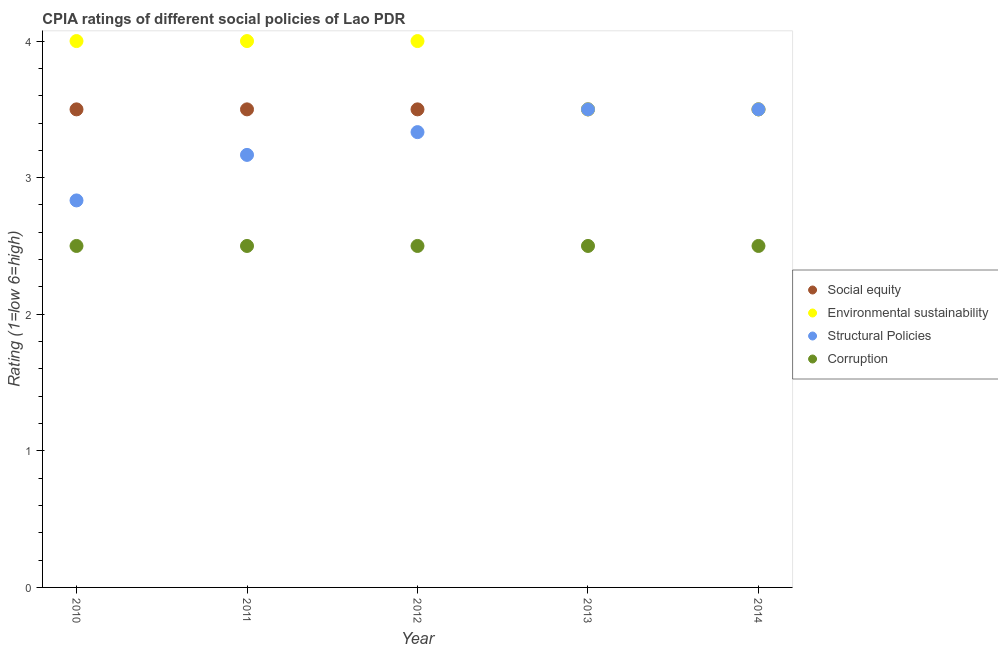How many different coloured dotlines are there?
Keep it short and to the point. 4. Is the number of dotlines equal to the number of legend labels?
Your answer should be very brief. Yes. What is the cpia rating of structural policies in 2012?
Your answer should be very brief. 3.33. Across all years, what is the maximum cpia rating of structural policies?
Make the answer very short. 3.5. In which year was the cpia rating of environmental sustainability maximum?
Keep it short and to the point. 2010. What is the difference between the cpia rating of environmental sustainability in 2011 and the cpia rating of structural policies in 2012?
Make the answer very short. 0.67. What is the average cpia rating of corruption per year?
Offer a very short reply. 2.5. What is the ratio of the cpia rating of corruption in 2013 to that in 2014?
Keep it short and to the point. 1. Is the cpia rating of corruption in 2012 less than that in 2014?
Keep it short and to the point. No. What is the difference between the highest and the second highest cpia rating of structural policies?
Offer a very short reply. 0. What is the difference between the highest and the lowest cpia rating of social equity?
Ensure brevity in your answer.  0. Is the sum of the cpia rating of environmental sustainability in 2012 and 2014 greater than the maximum cpia rating of social equity across all years?
Keep it short and to the point. Yes. How many years are there in the graph?
Your answer should be very brief. 5. Are the values on the major ticks of Y-axis written in scientific E-notation?
Your response must be concise. No. How many legend labels are there?
Offer a terse response. 4. What is the title of the graph?
Keep it short and to the point. CPIA ratings of different social policies of Lao PDR. Does "Primary schools" appear as one of the legend labels in the graph?
Your answer should be very brief. No. What is the label or title of the X-axis?
Provide a short and direct response. Year. What is the Rating (1=low 6=high) in Social equity in 2010?
Ensure brevity in your answer.  3.5. What is the Rating (1=low 6=high) of Environmental sustainability in 2010?
Your response must be concise. 4. What is the Rating (1=low 6=high) of Structural Policies in 2010?
Make the answer very short. 2.83. What is the Rating (1=low 6=high) in Environmental sustainability in 2011?
Give a very brief answer. 4. What is the Rating (1=low 6=high) of Structural Policies in 2011?
Your answer should be compact. 3.17. What is the Rating (1=low 6=high) in Social equity in 2012?
Your answer should be compact. 3.5. What is the Rating (1=low 6=high) in Structural Policies in 2012?
Your answer should be compact. 3.33. What is the Rating (1=low 6=high) in Corruption in 2012?
Keep it short and to the point. 2.5. What is the Rating (1=low 6=high) of Social equity in 2013?
Provide a short and direct response. 3.5. What is the Rating (1=low 6=high) of Structural Policies in 2013?
Ensure brevity in your answer.  3.5. What is the Rating (1=low 6=high) in Structural Policies in 2014?
Keep it short and to the point. 3.5. What is the Rating (1=low 6=high) of Corruption in 2014?
Your answer should be compact. 2.5. Across all years, what is the maximum Rating (1=low 6=high) in Environmental sustainability?
Your answer should be very brief. 4. Across all years, what is the maximum Rating (1=low 6=high) in Structural Policies?
Provide a succinct answer. 3.5. Across all years, what is the maximum Rating (1=low 6=high) of Corruption?
Keep it short and to the point. 2.5. Across all years, what is the minimum Rating (1=low 6=high) in Environmental sustainability?
Ensure brevity in your answer.  3.5. Across all years, what is the minimum Rating (1=low 6=high) of Structural Policies?
Ensure brevity in your answer.  2.83. Across all years, what is the minimum Rating (1=low 6=high) of Corruption?
Offer a very short reply. 2.5. What is the total Rating (1=low 6=high) in Social equity in the graph?
Provide a short and direct response. 17.5. What is the total Rating (1=low 6=high) in Structural Policies in the graph?
Provide a short and direct response. 16.33. What is the total Rating (1=low 6=high) in Corruption in the graph?
Make the answer very short. 12.5. What is the difference between the Rating (1=low 6=high) of Social equity in 2010 and that in 2011?
Make the answer very short. 0. What is the difference between the Rating (1=low 6=high) of Environmental sustainability in 2010 and that in 2011?
Your answer should be very brief. 0. What is the difference between the Rating (1=low 6=high) of Social equity in 2010 and that in 2012?
Your answer should be very brief. 0. What is the difference between the Rating (1=low 6=high) in Structural Policies in 2010 and that in 2012?
Offer a terse response. -0.5. What is the difference between the Rating (1=low 6=high) in Corruption in 2010 and that in 2012?
Your response must be concise. 0. What is the difference between the Rating (1=low 6=high) in Social equity in 2010 and that in 2013?
Offer a very short reply. 0. What is the difference between the Rating (1=low 6=high) of Structural Policies in 2010 and that in 2013?
Provide a succinct answer. -0.67. What is the difference between the Rating (1=low 6=high) of Corruption in 2010 and that in 2014?
Your answer should be compact. 0. What is the difference between the Rating (1=low 6=high) in Social equity in 2011 and that in 2012?
Provide a succinct answer. 0. What is the difference between the Rating (1=low 6=high) of Social equity in 2011 and that in 2013?
Give a very brief answer. 0. What is the difference between the Rating (1=low 6=high) in Environmental sustainability in 2011 and that in 2013?
Ensure brevity in your answer.  0.5. What is the difference between the Rating (1=low 6=high) of Structural Policies in 2011 and that in 2013?
Your response must be concise. -0.33. What is the difference between the Rating (1=low 6=high) in Corruption in 2011 and that in 2013?
Give a very brief answer. 0. What is the difference between the Rating (1=low 6=high) of Structural Policies in 2011 and that in 2014?
Make the answer very short. -0.33. What is the difference between the Rating (1=low 6=high) in Social equity in 2012 and that in 2013?
Keep it short and to the point. 0. What is the difference between the Rating (1=low 6=high) in Structural Policies in 2012 and that in 2013?
Your answer should be compact. -0.17. What is the difference between the Rating (1=low 6=high) of Corruption in 2012 and that in 2013?
Ensure brevity in your answer.  0. What is the difference between the Rating (1=low 6=high) in Social equity in 2012 and that in 2014?
Provide a short and direct response. 0. What is the difference between the Rating (1=low 6=high) in Structural Policies in 2012 and that in 2014?
Offer a terse response. -0.17. What is the difference between the Rating (1=low 6=high) of Social equity in 2013 and that in 2014?
Provide a succinct answer. 0. What is the difference between the Rating (1=low 6=high) of Social equity in 2010 and the Rating (1=low 6=high) of Structural Policies in 2011?
Offer a very short reply. 0.33. What is the difference between the Rating (1=low 6=high) in Environmental sustainability in 2010 and the Rating (1=low 6=high) in Structural Policies in 2011?
Your answer should be compact. 0.83. What is the difference between the Rating (1=low 6=high) in Environmental sustainability in 2010 and the Rating (1=low 6=high) in Corruption in 2011?
Offer a very short reply. 1.5. What is the difference between the Rating (1=low 6=high) in Environmental sustainability in 2010 and the Rating (1=low 6=high) in Structural Policies in 2012?
Make the answer very short. 0.67. What is the difference between the Rating (1=low 6=high) of Social equity in 2010 and the Rating (1=low 6=high) of Environmental sustainability in 2013?
Offer a very short reply. 0. What is the difference between the Rating (1=low 6=high) of Social equity in 2010 and the Rating (1=low 6=high) of Corruption in 2013?
Offer a very short reply. 1. What is the difference between the Rating (1=low 6=high) of Environmental sustainability in 2010 and the Rating (1=low 6=high) of Corruption in 2013?
Offer a very short reply. 1.5. What is the difference between the Rating (1=low 6=high) in Social equity in 2010 and the Rating (1=low 6=high) in Environmental sustainability in 2014?
Your answer should be compact. 0. What is the difference between the Rating (1=low 6=high) of Environmental sustainability in 2010 and the Rating (1=low 6=high) of Corruption in 2014?
Your answer should be very brief. 1.5. What is the difference between the Rating (1=low 6=high) in Social equity in 2011 and the Rating (1=low 6=high) in Environmental sustainability in 2012?
Offer a very short reply. -0.5. What is the difference between the Rating (1=low 6=high) of Social equity in 2011 and the Rating (1=low 6=high) of Structural Policies in 2012?
Ensure brevity in your answer.  0.17. What is the difference between the Rating (1=low 6=high) in Social equity in 2011 and the Rating (1=low 6=high) in Corruption in 2012?
Make the answer very short. 1. What is the difference between the Rating (1=low 6=high) of Environmental sustainability in 2011 and the Rating (1=low 6=high) of Structural Policies in 2012?
Offer a very short reply. 0.67. What is the difference between the Rating (1=low 6=high) of Environmental sustainability in 2011 and the Rating (1=low 6=high) of Corruption in 2012?
Give a very brief answer. 1.5. What is the difference between the Rating (1=low 6=high) in Social equity in 2011 and the Rating (1=low 6=high) in Structural Policies in 2013?
Your response must be concise. 0. What is the difference between the Rating (1=low 6=high) of Social equity in 2011 and the Rating (1=low 6=high) of Corruption in 2013?
Ensure brevity in your answer.  1. What is the difference between the Rating (1=low 6=high) of Environmental sustainability in 2011 and the Rating (1=low 6=high) of Structural Policies in 2013?
Provide a short and direct response. 0.5. What is the difference between the Rating (1=low 6=high) in Environmental sustainability in 2011 and the Rating (1=low 6=high) in Structural Policies in 2014?
Ensure brevity in your answer.  0.5. What is the difference between the Rating (1=low 6=high) in Environmental sustainability in 2011 and the Rating (1=low 6=high) in Corruption in 2014?
Provide a short and direct response. 1.5. What is the difference between the Rating (1=low 6=high) in Social equity in 2012 and the Rating (1=low 6=high) in Environmental sustainability in 2013?
Give a very brief answer. 0. What is the difference between the Rating (1=low 6=high) of Social equity in 2012 and the Rating (1=low 6=high) of Structural Policies in 2014?
Keep it short and to the point. 0. What is the difference between the Rating (1=low 6=high) of Social equity in 2013 and the Rating (1=low 6=high) of Environmental sustainability in 2014?
Give a very brief answer. 0. What is the difference between the Rating (1=low 6=high) of Environmental sustainability in 2013 and the Rating (1=low 6=high) of Structural Policies in 2014?
Provide a succinct answer. 0. What is the difference between the Rating (1=low 6=high) in Environmental sustainability in 2013 and the Rating (1=low 6=high) in Corruption in 2014?
Give a very brief answer. 1. What is the average Rating (1=low 6=high) in Social equity per year?
Provide a short and direct response. 3.5. What is the average Rating (1=low 6=high) in Structural Policies per year?
Offer a terse response. 3.27. What is the average Rating (1=low 6=high) of Corruption per year?
Make the answer very short. 2.5. In the year 2010, what is the difference between the Rating (1=low 6=high) in Social equity and Rating (1=low 6=high) in Environmental sustainability?
Provide a succinct answer. -0.5. In the year 2010, what is the difference between the Rating (1=low 6=high) of Social equity and Rating (1=low 6=high) of Structural Policies?
Provide a short and direct response. 0.67. In the year 2010, what is the difference between the Rating (1=low 6=high) of Structural Policies and Rating (1=low 6=high) of Corruption?
Keep it short and to the point. 0.33. In the year 2011, what is the difference between the Rating (1=low 6=high) in Social equity and Rating (1=low 6=high) in Structural Policies?
Your response must be concise. 0.33. In the year 2011, what is the difference between the Rating (1=low 6=high) in Environmental sustainability and Rating (1=low 6=high) in Corruption?
Provide a short and direct response. 1.5. In the year 2013, what is the difference between the Rating (1=low 6=high) of Social equity and Rating (1=low 6=high) of Structural Policies?
Offer a very short reply. 0. In the year 2013, what is the difference between the Rating (1=low 6=high) in Environmental sustainability and Rating (1=low 6=high) in Structural Policies?
Provide a short and direct response. 0. In the year 2013, what is the difference between the Rating (1=low 6=high) in Environmental sustainability and Rating (1=low 6=high) in Corruption?
Offer a terse response. 1. In the year 2013, what is the difference between the Rating (1=low 6=high) in Structural Policies and Rating (1=low 6=high) in Corruption?
Make the answer very short. 1. In the year 2014, what is the difference between the Rating (1=low 6=high) in Social equity and Rating (1=low 6=high) in Structural Policies?
Your answer should be compact. 0. What is the ratio of the Rating (1=low 6=high) in Environmental sustainability in 2010 to that in 2011?
Make the answer very short. 1. What is the ratio of the Rating (1=low 6=high) in Structural Policies in 2010 to that in 2011?
Ensure brevity in your answer.  0.89. What is the ratio of the Rating (1=low 6=high) of Environmental sustainability in 2010 to that in 2012?
Make the answer very short. 1. What is the ratio of the Rating (1=low 6=high) in Corruption in 2010 to that in 2012?
Ensure brevity in your answer.  1. What is the ratio of the Rating (1=low 6=high) of Structural Policies in 2010 to that in 2013?
Your answer should be very brief. 0.81. What is the ratio of the Rating (1=low 6=high) of Corruption in 2010 to that in 2013?
Provide a short and direct response. 1. What is the ratio of the Rating (1=low 6=high) of Social equity in 2010 to that in 2014?
Provide a short and direct response. 1. What is the ratio of the Rating (1=low 6=high) in Structural Policies in 2010 to that in 2014?
Give a very brief answer. 0.81. What is the ratio of the Rating (1=low 6=high) of Corruption in 2010 to that in 2014?
Your answer should be very brief. 1. What is the ratio of the Rating (1=low 6=high) in Corruption in 2011 to that in 2012?
Your answer should be compact. 1. What is the ratio of the Rating (1=low 6=high) in Structural Policies in 2011 to that in 2013?
Make the answer very short. 0.9. What is the ratio of the Rating (1=low 6=high) of Corruption in 2011 to that in 2013?
Ensure brevity in your answer.  1. What is the ratio of the Rating (1=low 6=high) in Social equity in 2011 to that in 2014?
Provide a succinct answer. 1. What is the ratio of the Rating (1=low 6=high) in Structural Policies in 2011 to that in 2014?
Provide a succinct answer. 0.9. What is the ratio of the Rating (1=low 6=high) in Corruption in 2011 to that in 2014?
Provide a succinct answer. 1. What is the ratio of the Rating (1=low 6=high) in Social equity in 2012 to that in 2013?
Offer a very short reply. 1. What is the ratio of the Rating (1=low 6=high) in Environmental sustainability in 2012 to that in 2013?
Your answer should be compact. 1.14. What is the ratio of the Rating (1=low 6=high) of Structural Policies in 2012 to that in 2013?
Provide a short and direct response. 0.95. What is the ratio of the Rating (1=low 6=high) of Social equity in 2012 to that in 2014?
Provide a succinct answer. 1. What is the ratio of the Rating (1=low 6=high) in Environmental sustainability in 2012 to that in 2014?
Offer a terse response. 1.14. What is the ratio of the Rating (1=low 6=high) in Corruption in 2012 to that in 2014?
Give a very brief answer. 1. What is the ratio of the Rating (1=low 6=high) of Social equity in 2013 to that in 2014?
Keep it short and to the point. 1. What is the ratio of the Rating (1=low 6=high) in Structural Policies in 2013 to that in 2014?
Provide a succinct answer. 1. What is the ratio of the Rating (1=low 6=high) of Corruption in 2013 to that in 2014?
Offer a terse response. 1. What is the difference between the highest and the lowest Rating (1=low 6=high) of Structural Policies?
Your answer should be compact. 0.67. What is the difference between the highest and the lowest Rating (1=low 6=high) of Corruption?
Give a very brief answer. 0. 